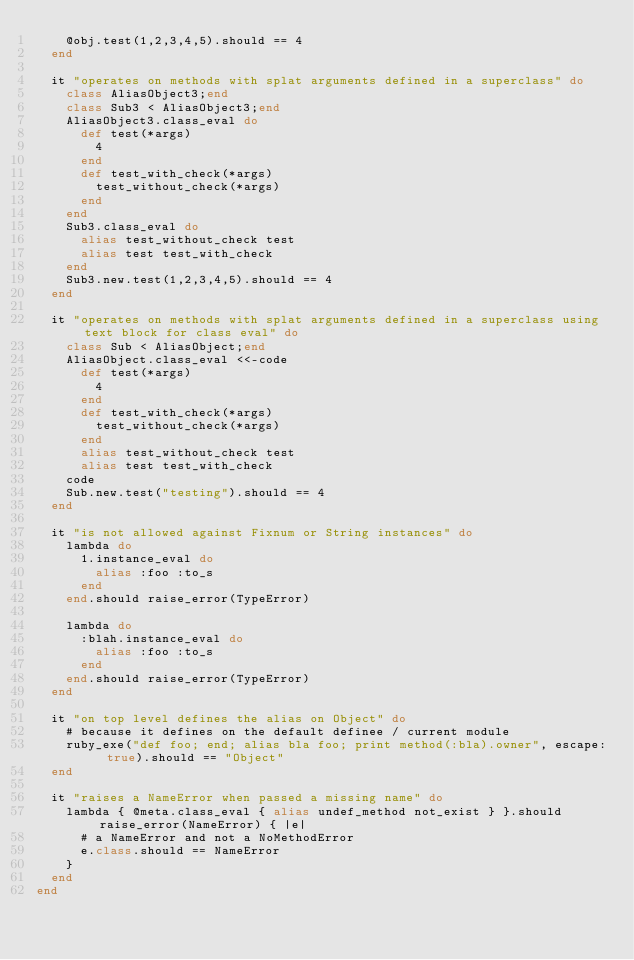Convert code to text. <code><loc_0><loc_0><loc_500><loc_500><_Ruby_>    @obj.test(1,2,3,4,5).should == 4
  end

  it "operates on methods with splat arguments defined in a superclass" do
    class AliasObject3;end
    class Sub3 < AliasObject3;end
    AliasObject3.class_eval do
      def test(*args)
        4
      end
      def test_with_check(*args)
        test_without_check(*args)
      end
    end
    Sub3.class_eval do
      alias test_without_check test
      alias test test_with_check
    end
    Sub3.new.test(1,2,3,4,5).should == 4
  end

  it "operates on methods with splat arguments defined in a superclass using text block for class eval" do
    class Sub < AliasObject;end
    AliasObject.class_eval <<-code
      def test(*args)
        4
      end
      def test_with_check(*args)
        test_without_check(*args)
      end
      alias test_without_check test
      alias test test_with_check
    code
    Sub.new.test("testing").should == 4
  end

  it "is not allowed against Fixnum or String instances" do
    lambda do
      1.instance_eval do
        alias :foo :to_s
      end
    end.should raise_error(TypeError)

    lambda do
      :blah.instance_eval do
        alias :foo :to_s
      end
    end.should raise_error(TypeError)
  end

  it "on top level defines the alias on Object" do
    # because it defines on the default definee / current module
    ruby_exe("def foo; end; alias bla foo; print method(:bla).owner", escape: true).should == "Object"
  end

  it "raises a NameError when passed a missing name" do
    lambda { @meta.class_eval { alias undef_method not_exist } }.should raise_error(NameError) { |e|
      # a NameError and not a NoMethodError
      e.class.should == NameError
    }
  end
end
</code> 